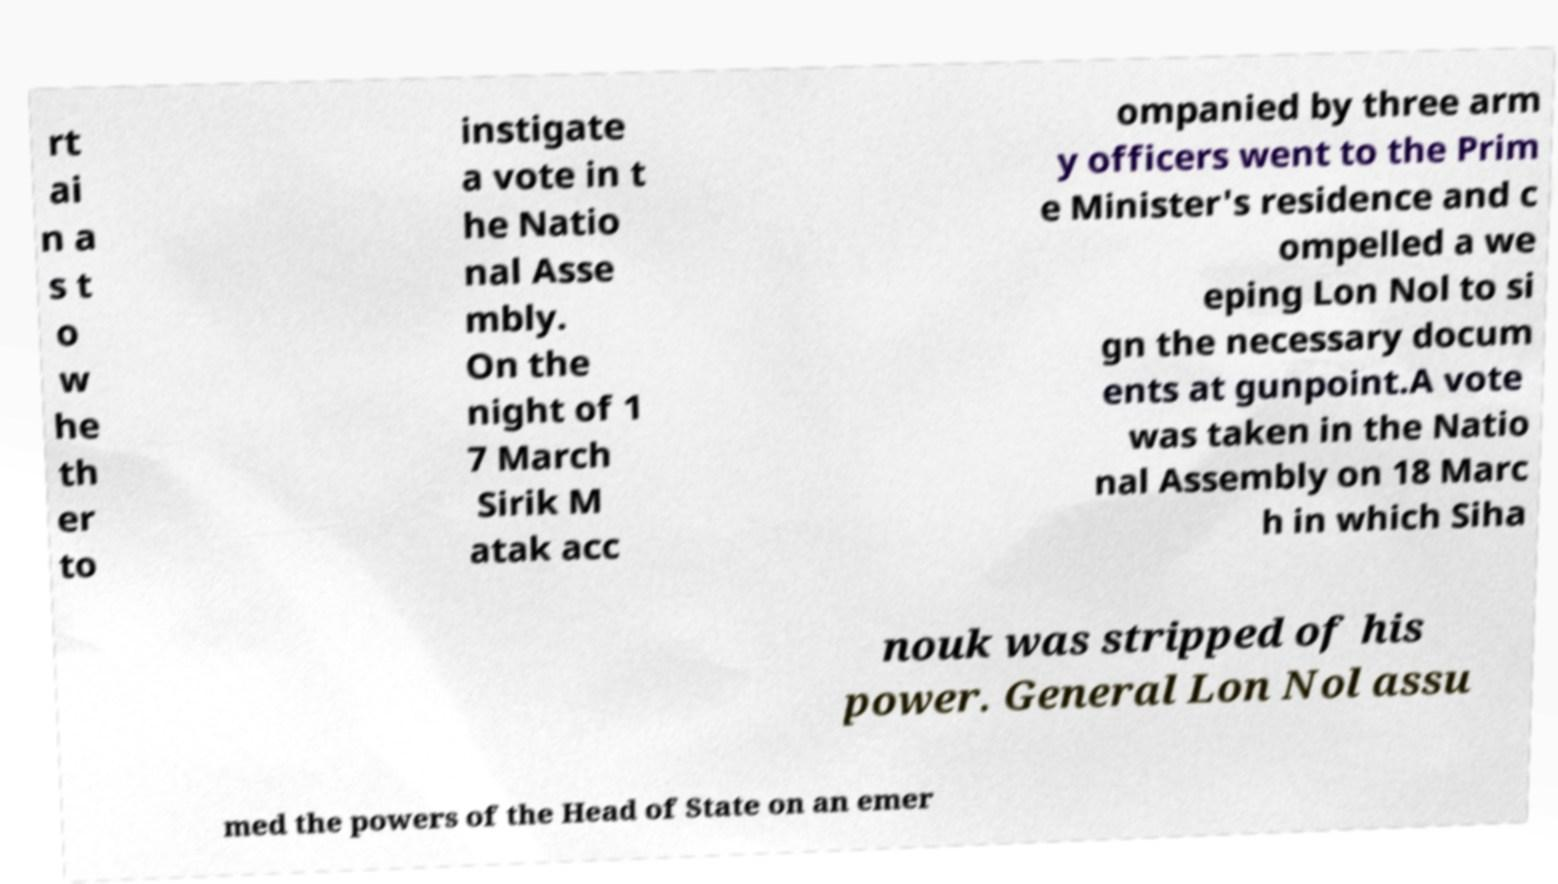I need the written content from this picture converted into text. Can you do that? rt ai n a s t o w he th er to instigate a vote in t he Natio nal Asse mbly. On the night of 1 7 March Sirik M atak acc ompanied by three arm y officers went to the Prim e Minister's residence and c ompelled a we eping Lon Nol to si gn the necessary docum ents at gunpoint.A vote was taken in the Natio nal Assembly on 18 Marc h in which Siha nouk was stripped of his power. General Lon Nol assu med the powers of the Head of State on an emer 